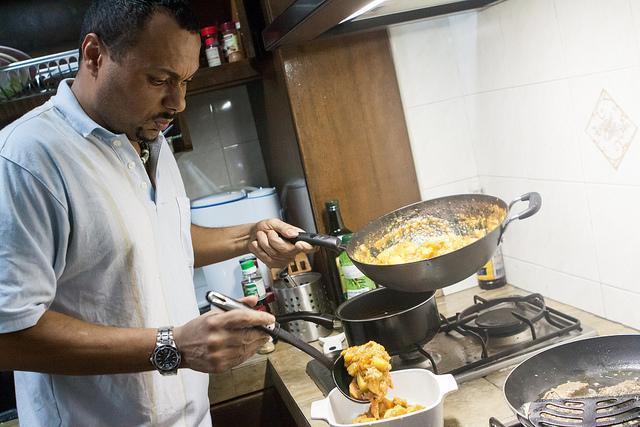How many birds are on the tree?
Give a very brief answer. 0. 